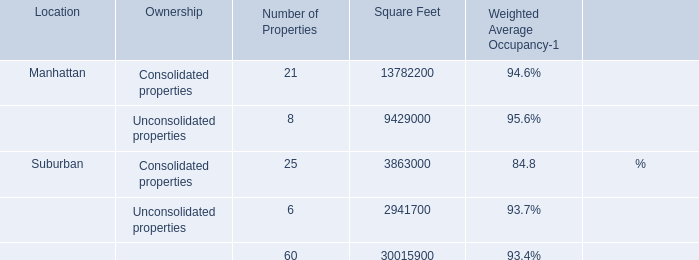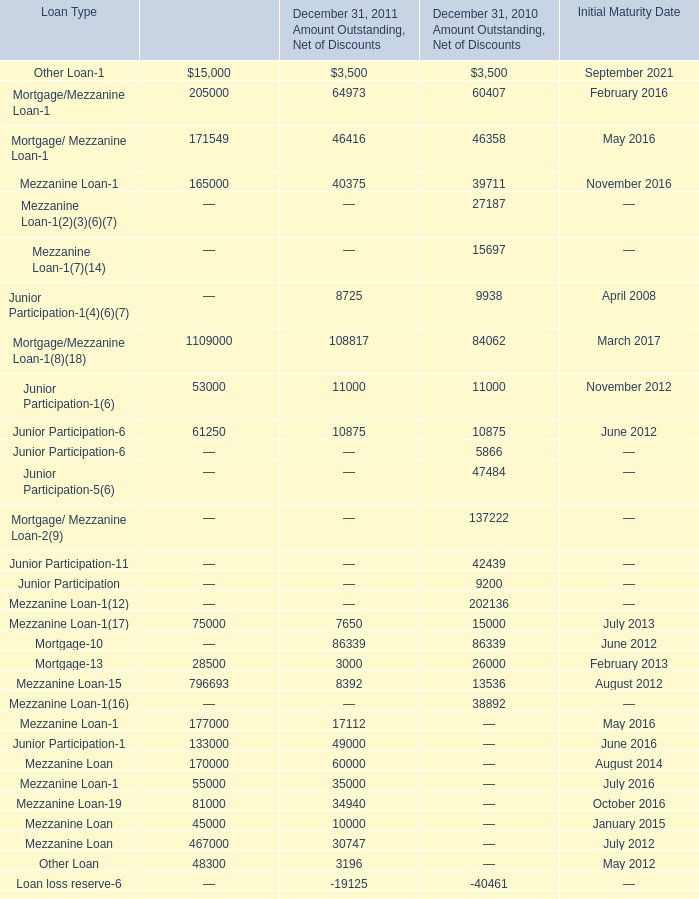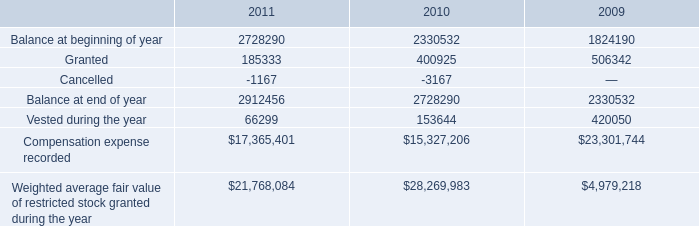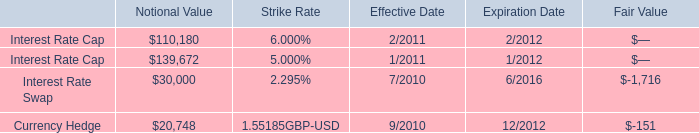What is the sum of Mortgage of December 31, 2011 Amount Outstanding, Net of Discounts, Vested during the year of 2010, and Mortgage/Mezzanine Loan of December 31, 2011 Senior Financing ? 
Computations: ((3000.0 + 153644.0) + 1109000.0)
Answer: 1265644.0. 